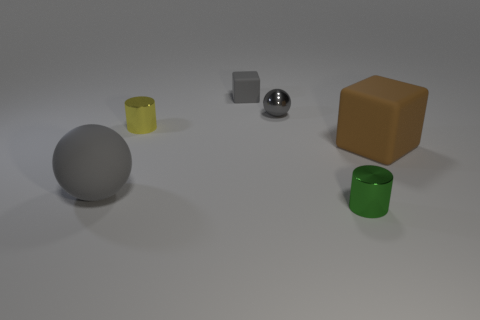Add 1 gray shiny things. How many objects exist? 7 Subtract all blocks. How many objects are left? 4 Add 3 small yellow cylinders. How many small yellow cylinders exist? 4 Subtract 0 cyan blocks. How many objects are left? 6 Subtract all gray metallic spheres. Subtract all gray metal balls. How many objects are left? 4 Add 1 tiny metal cylinders. How many tiny metal cylinders are left? 3 